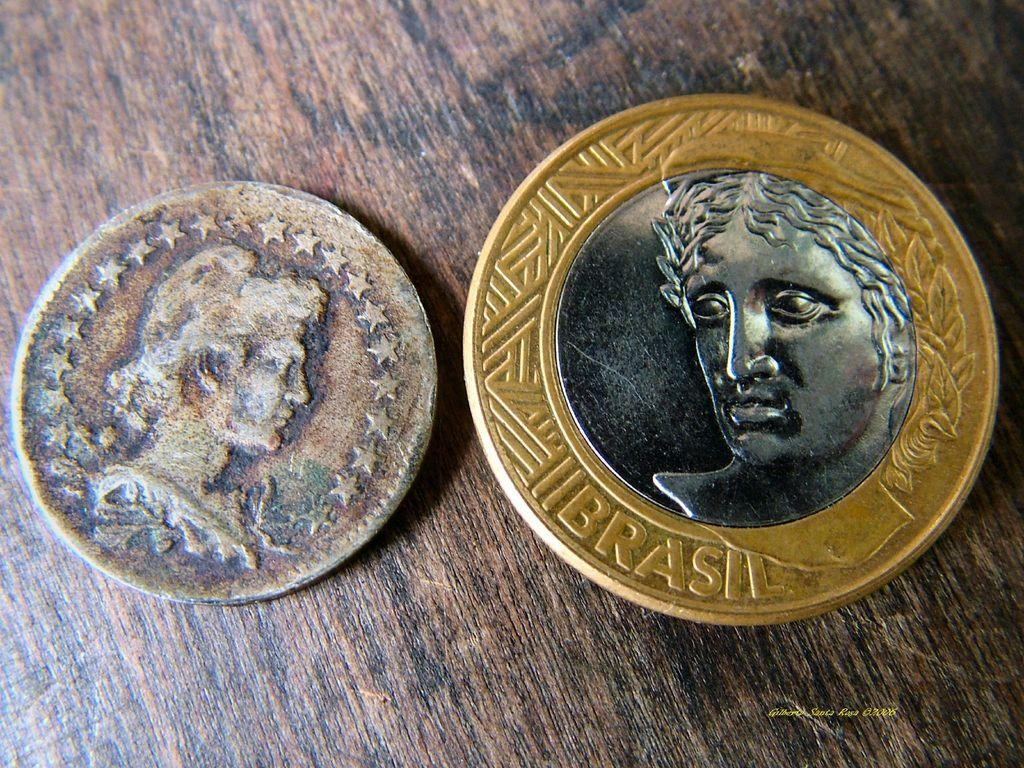<image>
Give a short and clear explanation of the subsequent image. two coins sit on a table next to each other, the one on the right is from Brasil. 